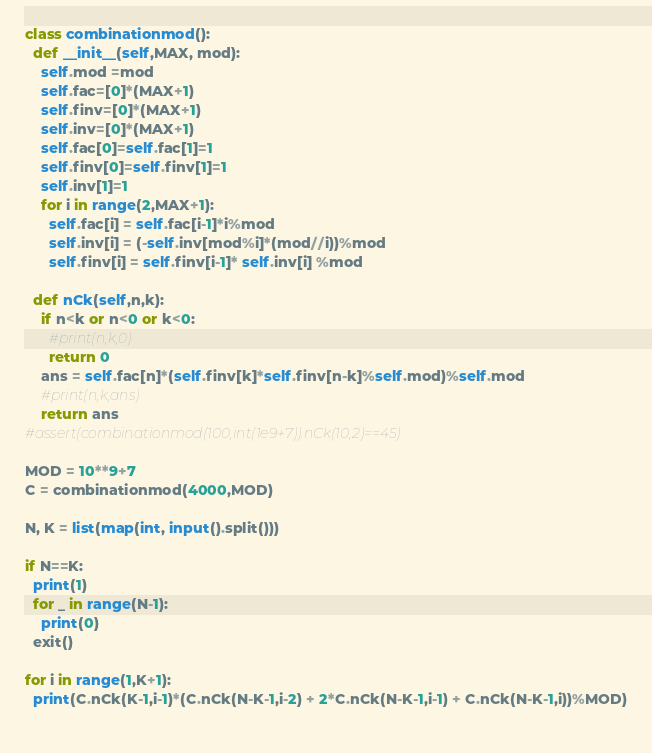<code> <loc_0><loc_0><loc_500><loc_500><_Python_>class combinationmod():
  def __init__(self,MAX, mod):
    self.mod =mod
    self.fac=[0]*(MAX+1)
    self.finv=[0]*(MAX+1)
    self.inv=[0]*(MAX+1)
    self.fac[0]=self.fac[1]=1
    self.finv[0]=self.finv[1]=1
    self.inv[1]=1
    for i in range(2,MAX+1):
      self.fac[i] = self.fac[i-1]*i%mod
      self.inv[i] = (-self.inv[mod%i]*(mod//i))%mod
      self.finv[i] = self.finv[i-1]* self.inv[i] %mod

  def nCk(self,n,k):
    if n<k or n<0 or k<0:
      #print(n,k,0)
      return 0
    ans = self.fac[n]*(self.finv[k]*self.finv[n-k]%self.mod)%self.mod
    #print(n,k,ans)
    return ans
#assert(combinationmod(100,int(1e9+7)).nCk(10,2)==45)

MOD = 10**9+7
C = combinationmod(4000,MOD)

N, K = list(map(int, input().split()))

if N==K:
  print(1)
  for _ in range(N-1):
    print(0)
  exit()

for i in range(1,K+1):
  print(C.nCk(K-1,i-1)*(C.nCk(N-K-1,i-2) + 2*C.nCk(N-K-1,i-1) + C.nCk(N-K-1,i))%MOD)
  
</code> 